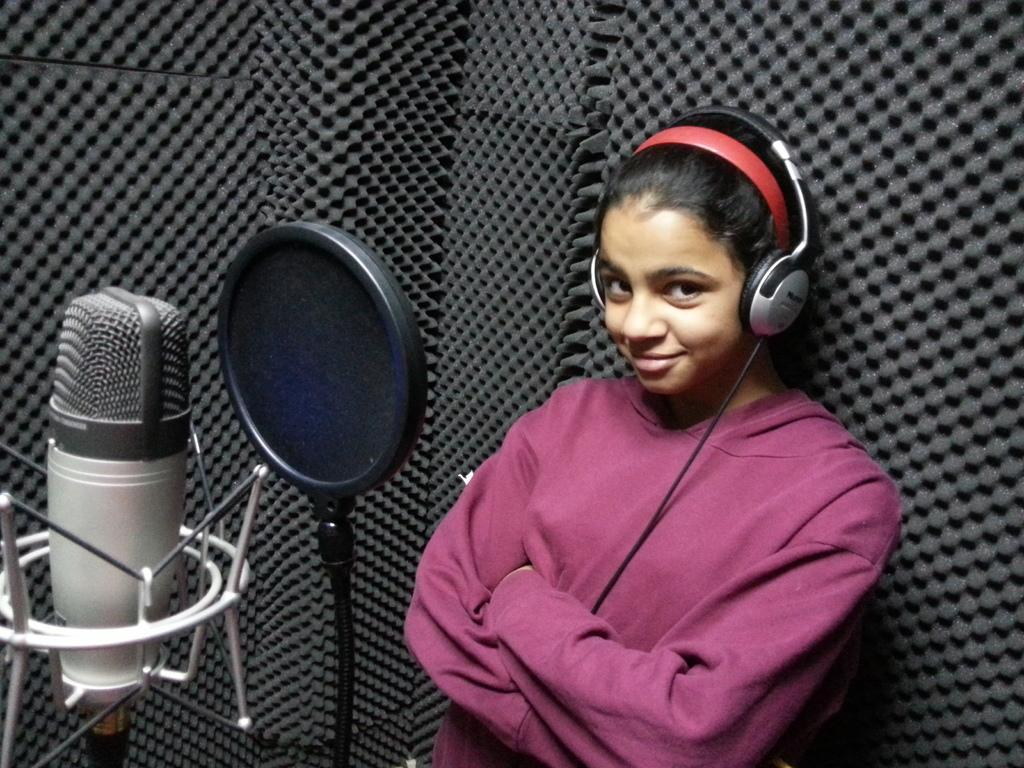Describe this image in one or two sentences. Here I can see a woman wearing t-shirt, headset, smiling and looking at the picture. On the left side there is a recording microphone. In the background there is a black surface. 